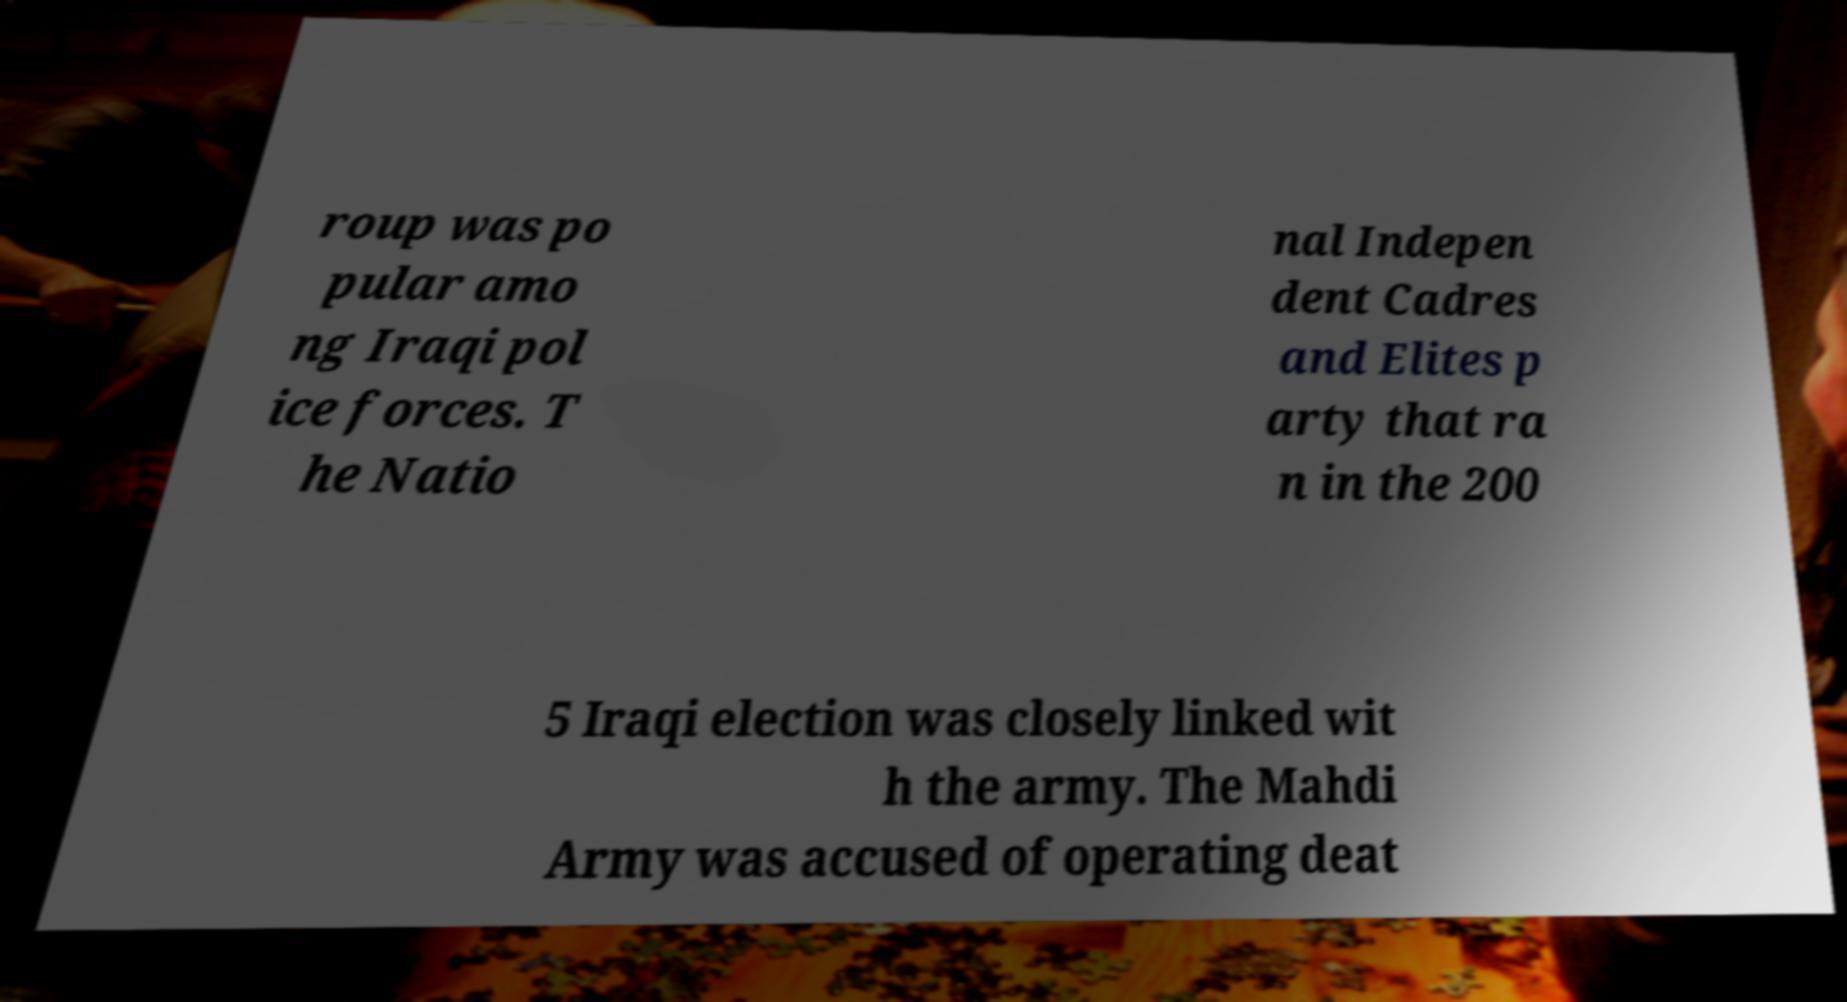Please read and relay the text visible in this image. What does it say? roup was po pular amo ng Iraqi pol ice forces. T he Natio nal Indepen dent Cadres and Elites p arty that ra n in the 200 5 Iraqi election was closely linked wit h the army. The Mahdi Army was accused of operating deat 